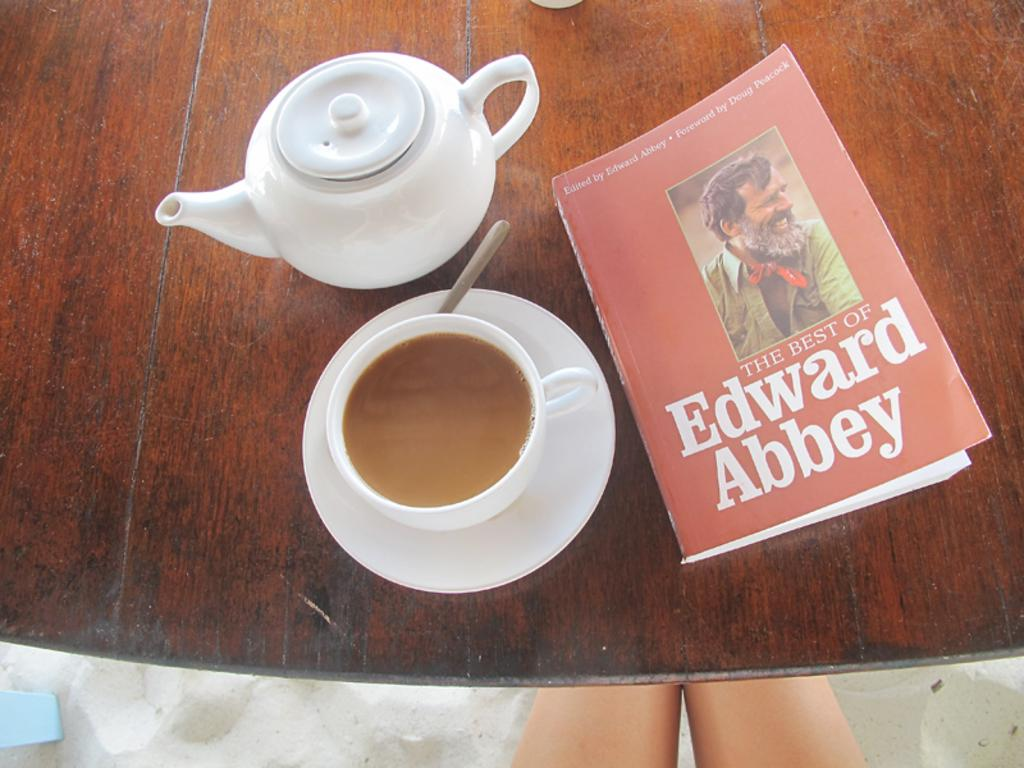<image>
Relay a brief, clear account of the picture shown. a book titled 'the best of edward abbey' sitting next to a cup of coffee 